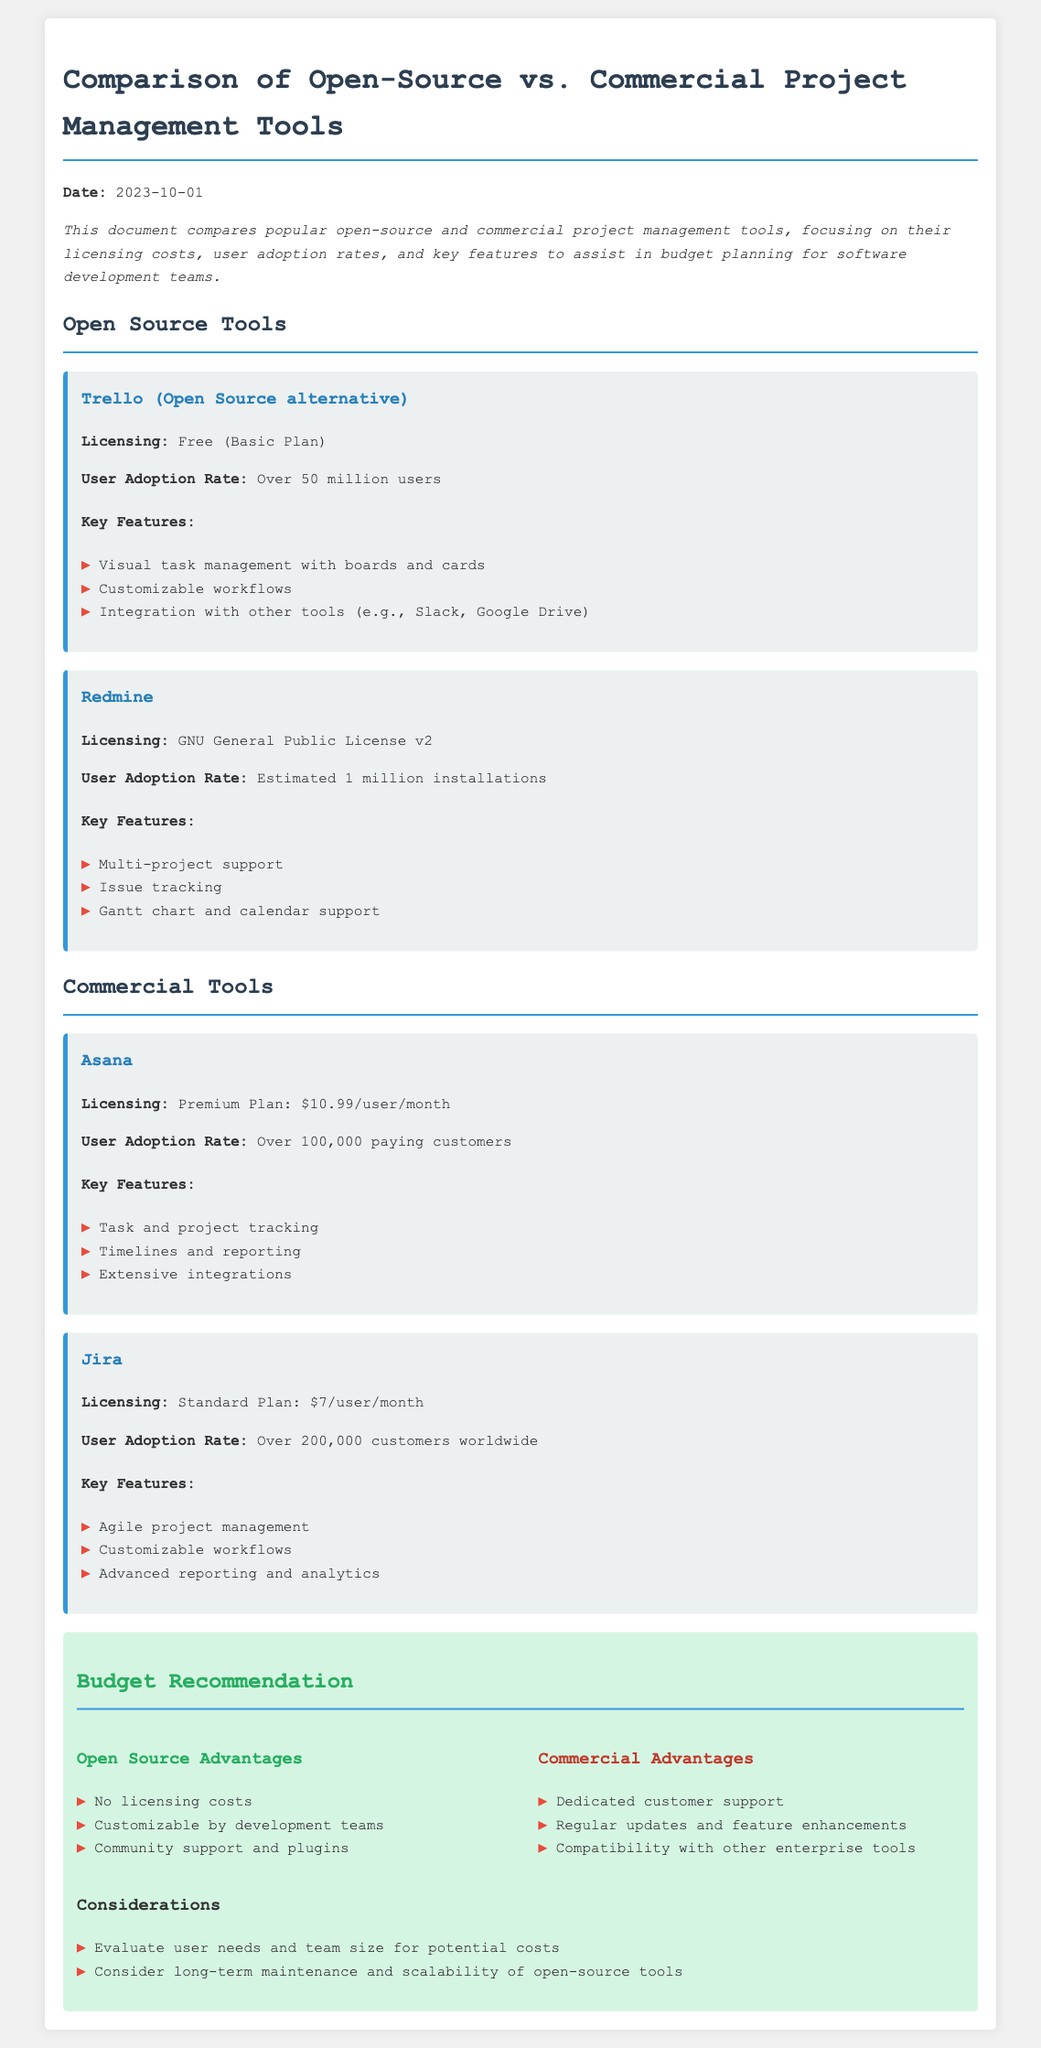What is the licensing cost for Asana? Asana's licensing cost is detailed under its section, which states the Premium Plan costs $10.99 per user per month.
Answer: $10.99/user/month What is the user adoption rate of Trello? Trello’s user adoption rate is mentioned as "Over 50 million users."
Answer: Over 50 million users What is the licensing type of Redmine? Redmine's licensing is specified as "GNU General Public License v2" in its section.
Answer: GNU General Public License v2 What are the advantages of open-source tools mentioned? The document lists advantages under the "Open Source Advantages" section, including no licensing costs and customizable by development teams.
Answer: No licensing costs, customizable by development teams Which commercial tool has the highest number of reported users? The document provides user adoption rates for commercial tools, indicating Jira has "Over 200,000 customers worldwide."
Answer: Over 200,000 customers worldwide What is a key feature of Jira? Jira's section lists several features, and one of them is "Agile project management."
Answer: Agile project management What considerations are mentioned for evaluating tools? The considerations listed include evaluating user needs and team size for potential costs and considering long-term maintenance.
Answer: Evaluate user needs and team size for potential costs What is the date of the document? The document states the date at the beginning as "2023-10-01."
Answer: 2023-10-01 What is a key feature of Asana? Asana's features include "Task and project tracking," mentioned in its description.
Answer: Task and project tracking 